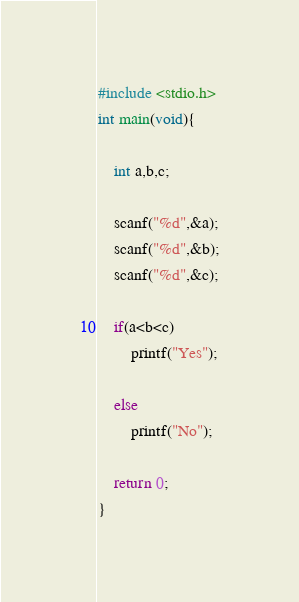<code> <loc_0><loc_0><loc_500><loc_500><_C_>#include <stdio.h>
int main(void){
    
    int a,b,c;
    
    scanf("%d",&a);
    scanf("%d",&b);
    scanf("%d",&c);
    
    if(a<b<c)
        printf("Yes");
    
    else
        printf("No");
    
    return 0;
}

</code> 